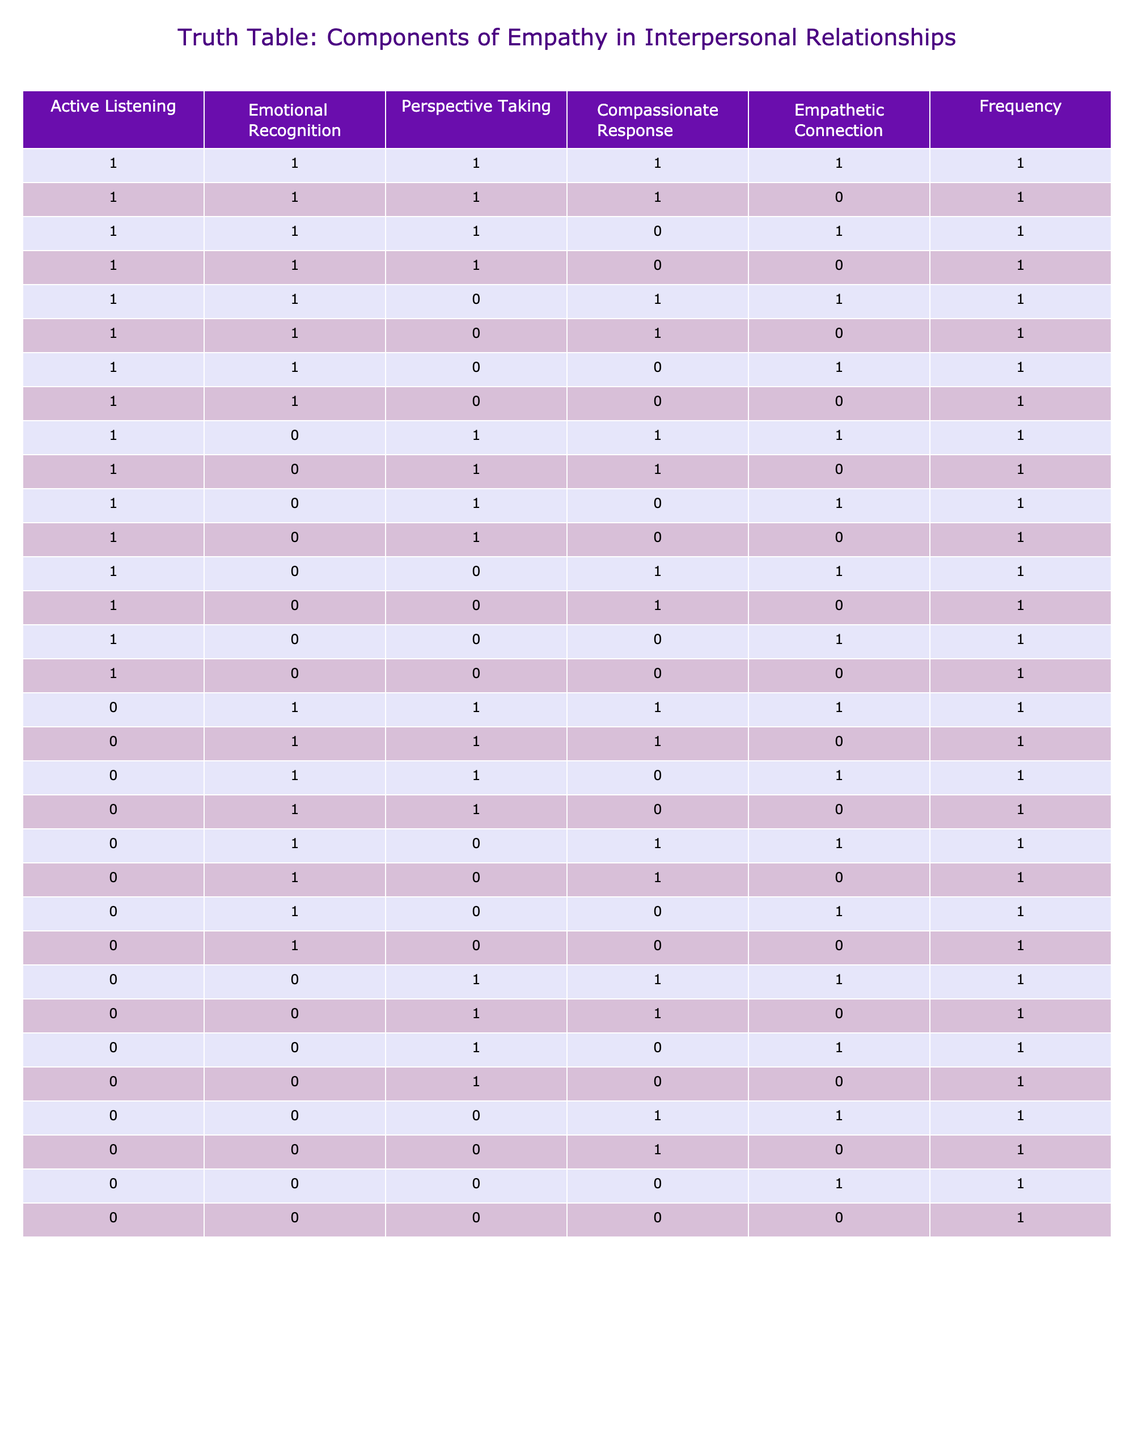What is the maximum number of components of empathy that can be present in a single row? The maximum value for each component is 1, meaning it can either be present (1) or absent (0). Looking through the rows, the highest total occurs in the rows where all components are present, which is 5 (1 for each of Active Listening, Emotional Recognition, Perspective Taking, Compassionate Response, and Empathetic Connection).
Answer: 5 How many rows contain a combination of active listening and emotional recognition but not compassionate response? By examining the rows where Active Listening and Emotional Recognition are both 1, we filter those for which Compassionate Response is 0. Found 6 rows that meet this criteria.
Answer: 6 Is there a row where all components except for perspective taking are active? Yes, when we search for 1s in Active Listening, Emotional Recognition, and Compassionate Response while filtering for 0 in Perspective Taking, we see two rows fit this description.
Answer: Yes What is the frequency of rows with no components of empathy present? Reviewing the rows, the specific combination of all components being 0 occurs only once in the table. That row indicates the absence of empathy components altogether.
Answer: 1 What is the average number of active components of empathy across all rows? First, count the total active components (summing all 1s) across all rows, which amounts to 34. Next, since there are 32 total entries, we calculate the average as 34 divided by 32, yielding an average of 1.06.
Answer: 1.06 Are there any combinations of components where empathetic connection is always absent? By analyzing the data, we note that combinations where Empathetic Connection is 0 include various situations with differing levels of other components, hence, yes, there are several combinations fitting this condition.
Answer: Yes What percentage of rows show a compassionate response present? To determine this, we count the rows where Compassionate Response is 1, which is 15 out of 32 rows. Then, we calculate the percentage as (15/32) multiplied by 100, resulting in approximately 46.88%.
Answer: 46.88% How many rows include all components except for emotional recognition? We search the rows for combinations where Emotional Recognition is 0, but all other components are 1. This configuration yields exactly 2 rows.
Answer: 2 What combinations have a compassionate response but lack both active listening and emotional recognition? By investigating the rows, we can see that when Active Listening and Emotional Recognition are both 0 while Compassionate Response is 1, only one such combination exists.
Answer: 1 